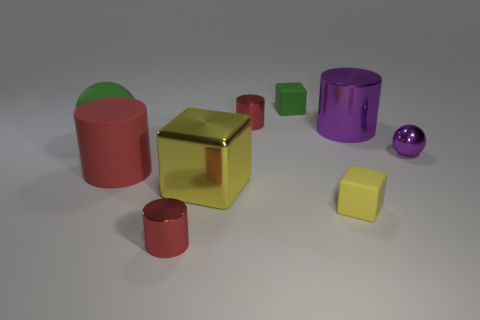There is a block behind the big green sphere; what material is it?
Ensure brevity in your answer.  Rubber. Do the big red rubber thing and the big purple shiny thing have the same shape?
Ensure brevity in your answer.  Yes. Are there any other things of the same color as the big shiny cylinder?
Provide a short and direct response. Yes. The other large object that is the same shape as the large red matte object is what color?
Ensure brevity in your answer.  Purple. Is the number of large purple shiny objects in front of the large metal block greater than the number of yellow blocks?
Offer a terse response. No. What color is the matte object that is to the left of the red matte cylinder?
Provide a short and direct response. Green. Do the green matte cube and the red matte cylinder have the same size?
Keep it short and to the point. No. How big is the purple cylinder?
Offer a terse response. Large. There is a object that is the same color as the metallic cube; what is its shape?
Your answer should be very brief. Cube. Is the number of large metal cubes greater than the number of big gray cylinders?
Offer a very short reply. Yes. 